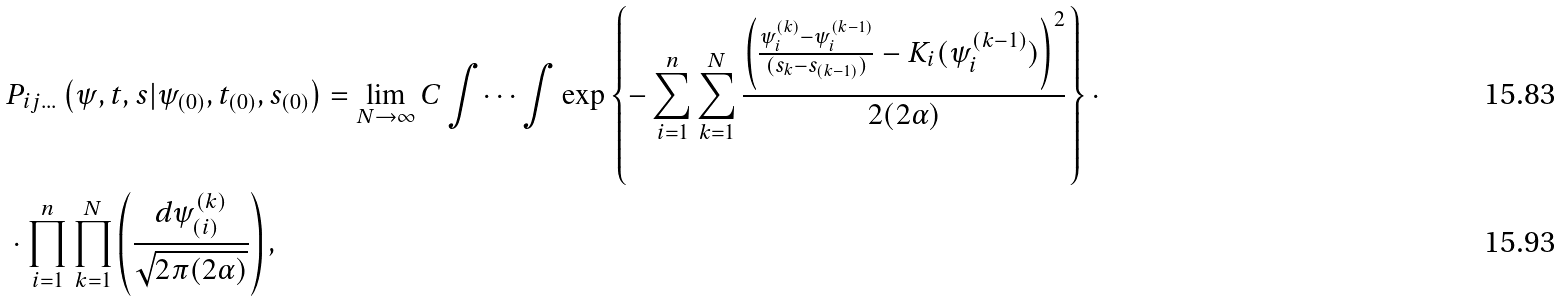Convert formula to latex. <formula><loc_0><loc_0><loc_500><loc_500>& P _ { i j \dots } \left ( \psi , t , s | \psi _ { ( 0 ) } , t _ { ( 0 ) } , s _ { ( 0 ) } \right ) = \lim _ { N \to \infty } C \int \dots \int \exp \left \{ - \sum _ { i = 1 } ^ { n } \sum _ { k = 1 } ^ { N } \frac { \left ( \frac { \psi _ { i } ^ { ( k ) } - \psi _ { i } ^ { ( k - 1 ) } } { ( s _ { k } - s _ { ( k - 1 ) } ) } - K _ { i } ( \psi _ { i } ^ { ( k - 1 ) } ) \right ) ^ { 2 } } { 2 ( 2 \alpha ) } \right \} \cdot \\ & \cdot \prod _ { i = 1 } ^ { n } \prod _ { k = 1 } ^ { N } \left ( \frac { d \psi _ { ( i ) } ^ { ( k ) } } { \sqrt { 2 \pi ( 2 \alpha ) } } \right ) ,</formula> 